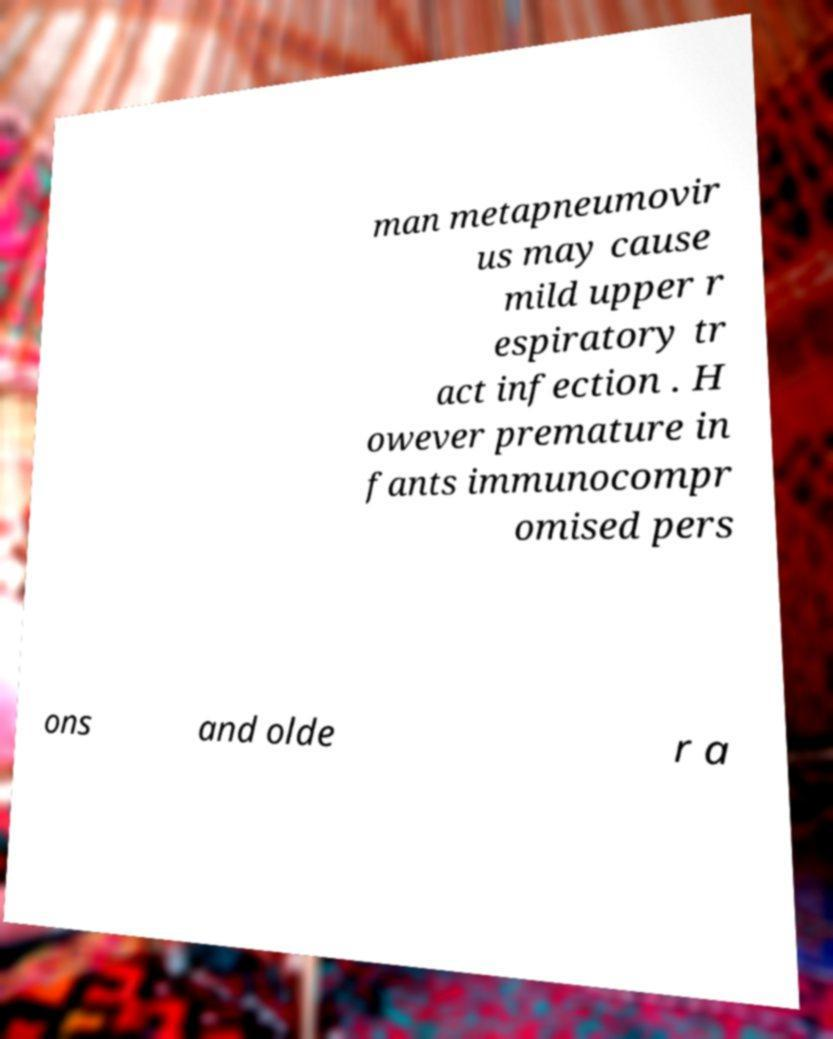Please identify and transcribe the text found in this image. man metapneumovir us may cause mild upper r espiratory tr act infection . H owever premature in fants immunocompr omised pers ons and olde r a 